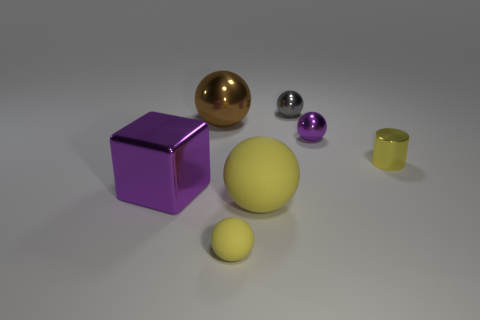Subtract all purple spheres. Subtract all green cylinders. How many spheres are left? 4 Add 1 small green objects. How many objects exist? 8 Subtract all spheres. How many objects are left? 2 Subtract 0 brown cubes. How many objects are left? 7 Subtract all small yellow spheres. Subtract all big spheres. How many objects are left? 4 Add 2 big matte balls. How many big matte balls are left? 3 Add 5 rubber balls. How many rubber balls exist? 7 